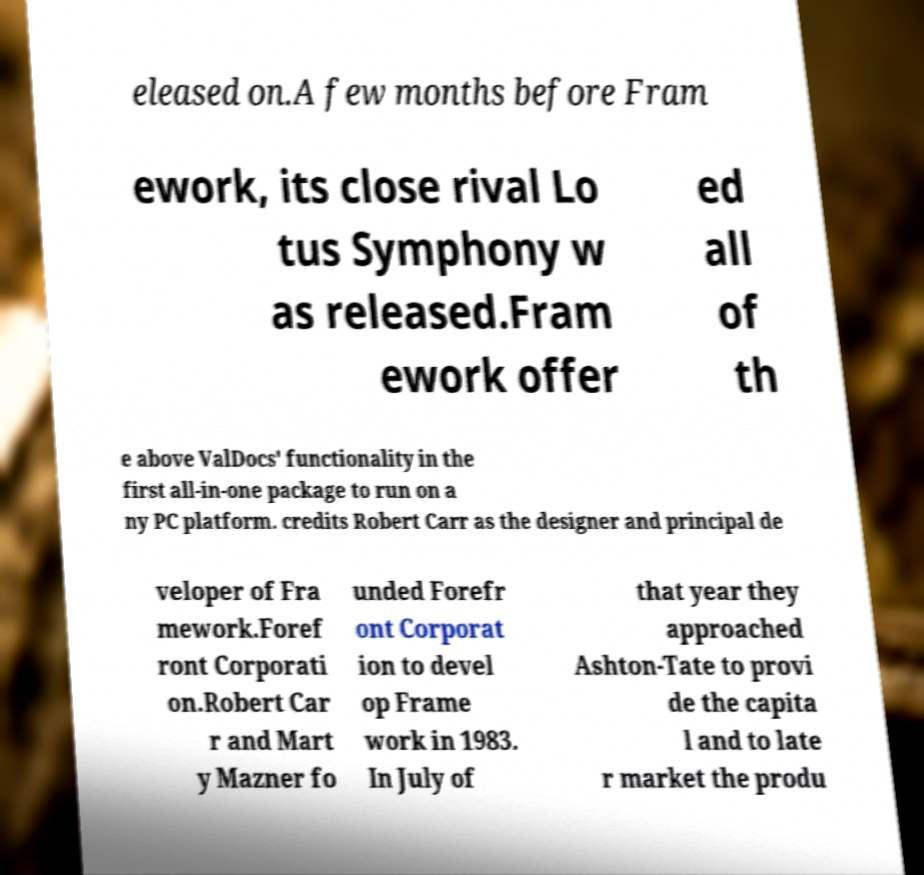Can you read and provide the text displayed in the image?This photo seems to have some interesting text. Can you extract and type it out for me? eleased on.A few months before Fram ework, its close rival Lo tus Symphony w as released.Fram ework offer ed all of th e above ValDocs' functionality in the first all-in-one package to run on a ny PC platform. credits Robert Carr as the designer and principal de veloper of Fra mework.Foref ront Corporati on.Robert Car r and Mart y Mazner fo unded Forefr ont Corporat ion to devel op Frame work in 1983. In July of that year they approached Ashton-Tate to provi de the capita l and to late r market the produ 